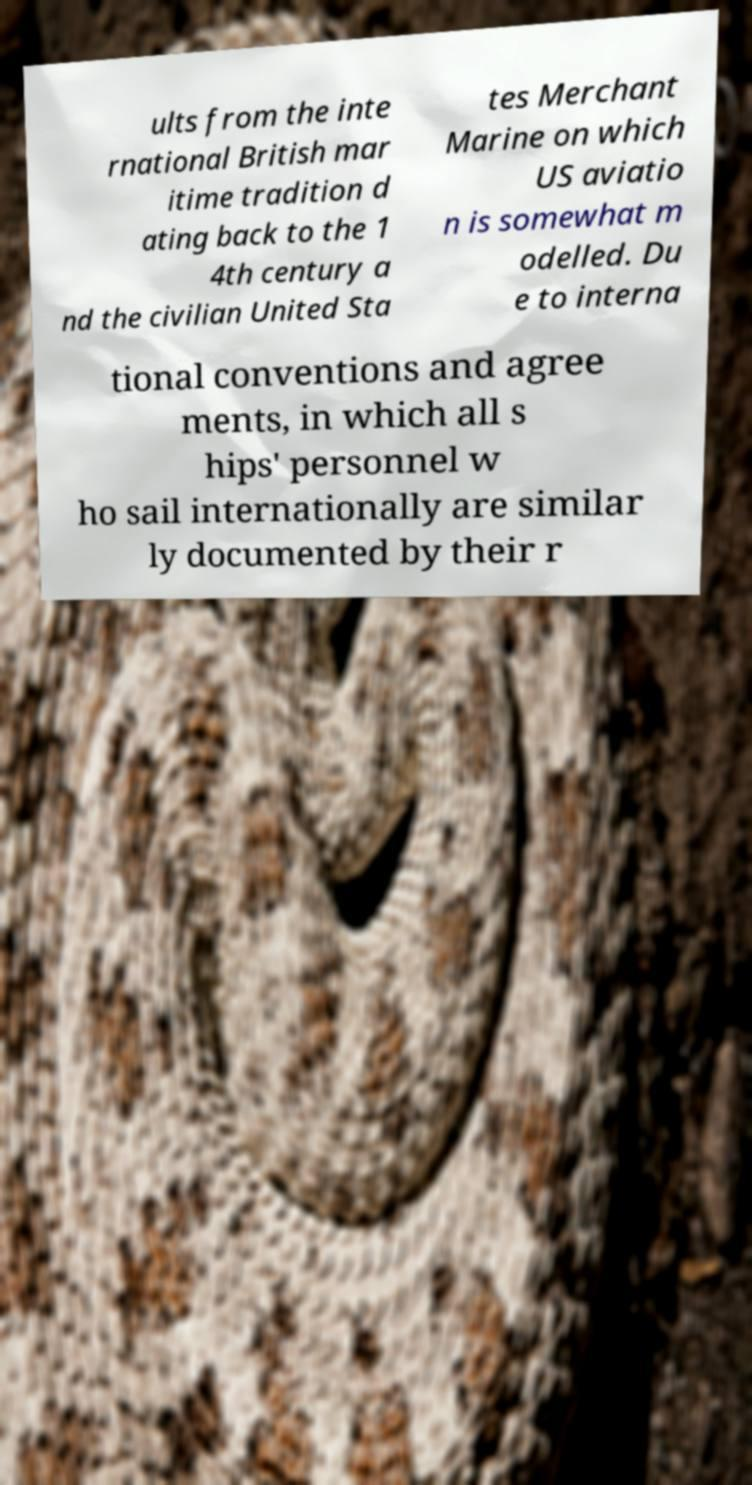What messages or text are displayed in this image? I need them in a readable, typed format. ults from the inte rnational British mar itime tradition d ating back to the 1 4th century a nd the civilian United Sta tes Merchant Marine on which US aviatio n is somewhat m odelled. Du e to interna tional conventions and agree ments, in which all s hips' personnel w ho sail internationally are similar ly documented by their r 